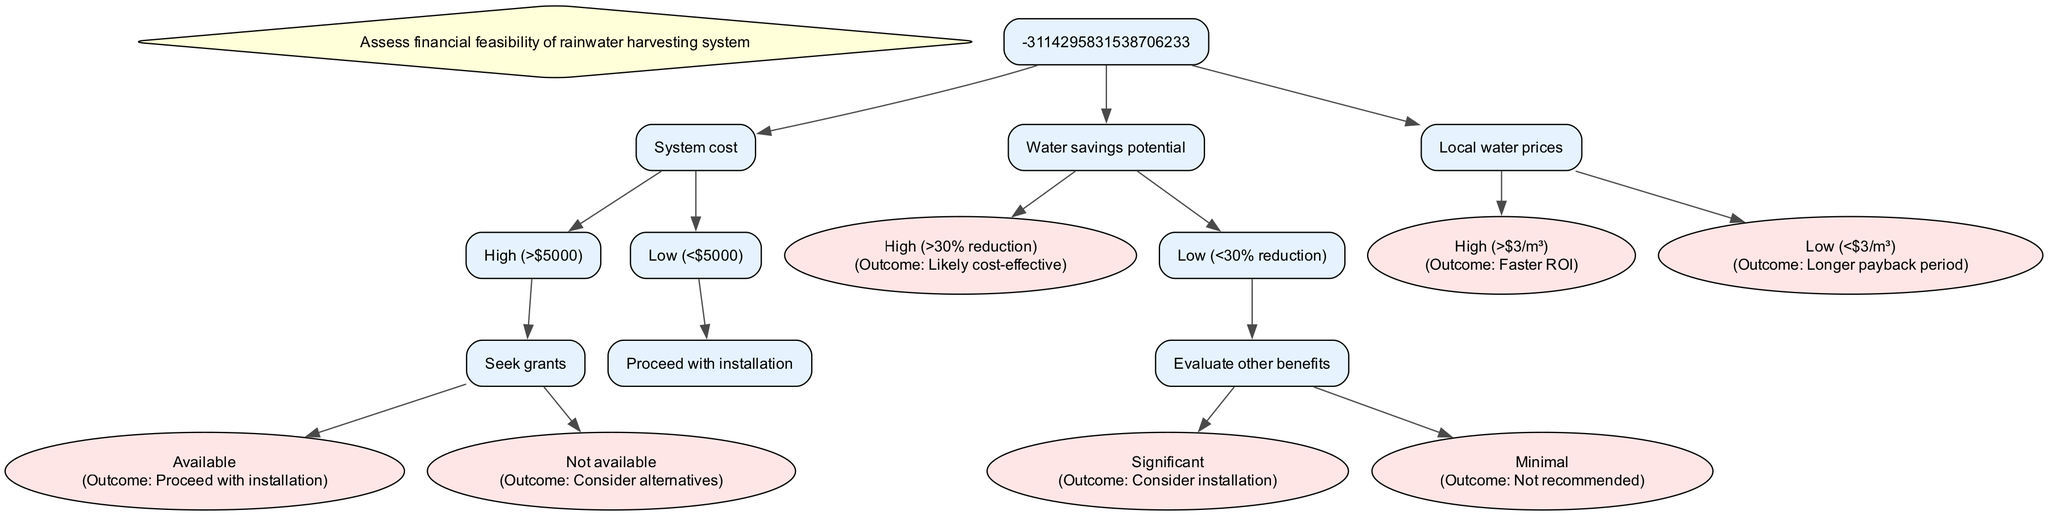What is the root question of this decision tree? The root question, which is the starting point of the decision-making process in this diagram, is specified at the top of the diagram and asks about the overall assessment of financial feasibility for a rainwater harvesting system.
Answer: Assess financial feasibility of rainwater harvesting system How many nodes are there in total in this diagram? By counting the main decision points and outcomes in the diagram, including the root, there are a total of seven nodes to consider.
Answer: Seven What happens if the system cost is low? If the system cost is low, meaning it is less than five thousand dollars, the next action is to proceed with the installation regardless of other considerations.
Answer: Proceed with installation What is the outcome if water savings potential is high? If the potential for water savings is high, which is defined as a reduction greater than thirty percent, the decision is straightforward and indicates that the investment is likely to be cost-effective.
Answer: Likely cost-effective What is the implication of high local water prices in the diagram? The diagram specifies that if local water prices are high, meaning greater than three dollars per cubic meter, it implies a faster return on investment for the rainwater harvesting system.
Answer: Faster ROI What should be evaluated if water savings potential is low? In cases where the water savings potential is low, defined as less than a thirty percent reduction, the next step, as per the diagram, is to evaluate other benefits related to installation to inform the decision-making process.
Answer: Evaluate other benefits What is the outcome if grants are not available for high-cost systems? If grants are not available for systems that are deemed high-cost, which is more than five thousand dollars, the suggested action is to consider alternatives to installation rather than proceeding with the project.
Answer: Consider alternatives 